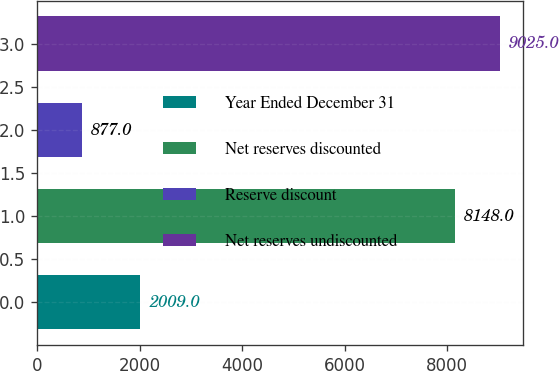Convert chart. <chart><loc_0><loc_0><loc_500><loc_500><bar_chart><fcel>Year Ended December 31<fcel>Net reserves discounted<fcel>Reserve discount<fcel>Net reserves undiscounted<nl><fcel>2009<fcel>8148<fcel>877<fcel>9025<nl></chart> 